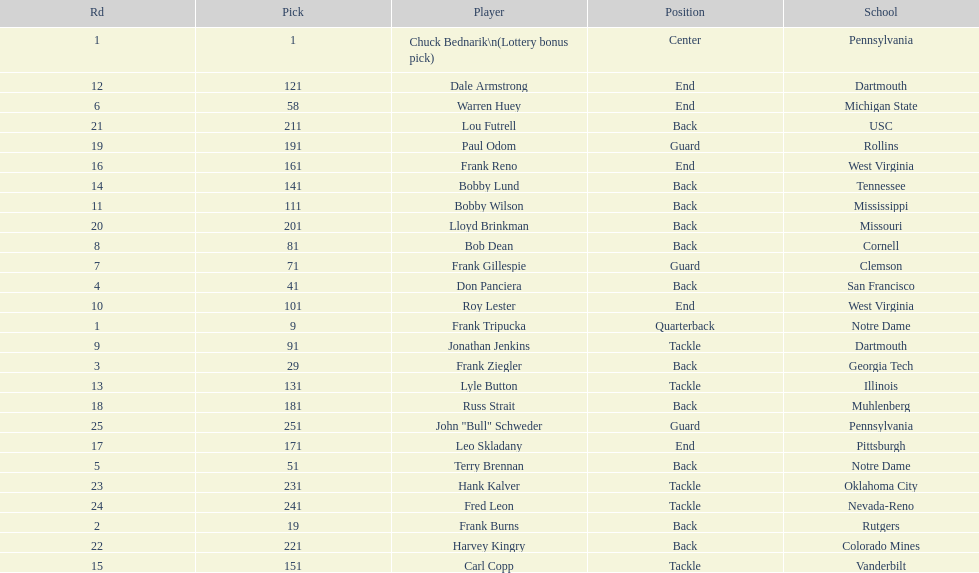Who was picked after roy lester? Bobby Wilson. 